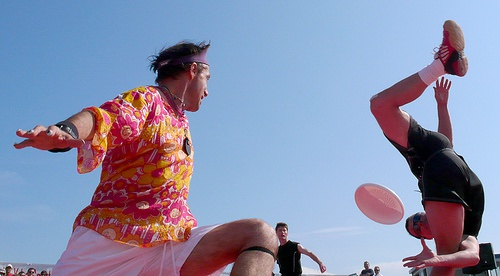Describe the objects in this image and their specific colors. I can see people in gray, maroon, and brown tones, people in gray, black, maroon, and purple tones, frisbee in gray, brown, and salmon tones, and people in gray, black, brown, and maroon tones in this image. 